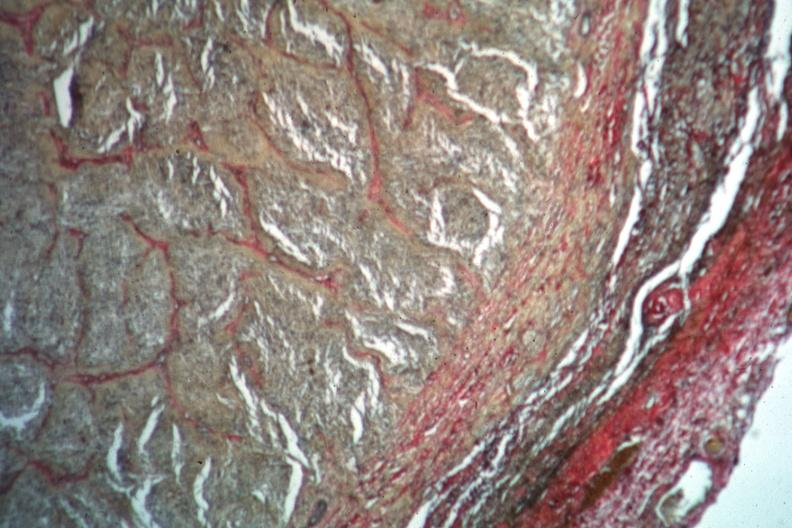does this image show van gieson?
Answer the question using a single word or phrase. Yes 